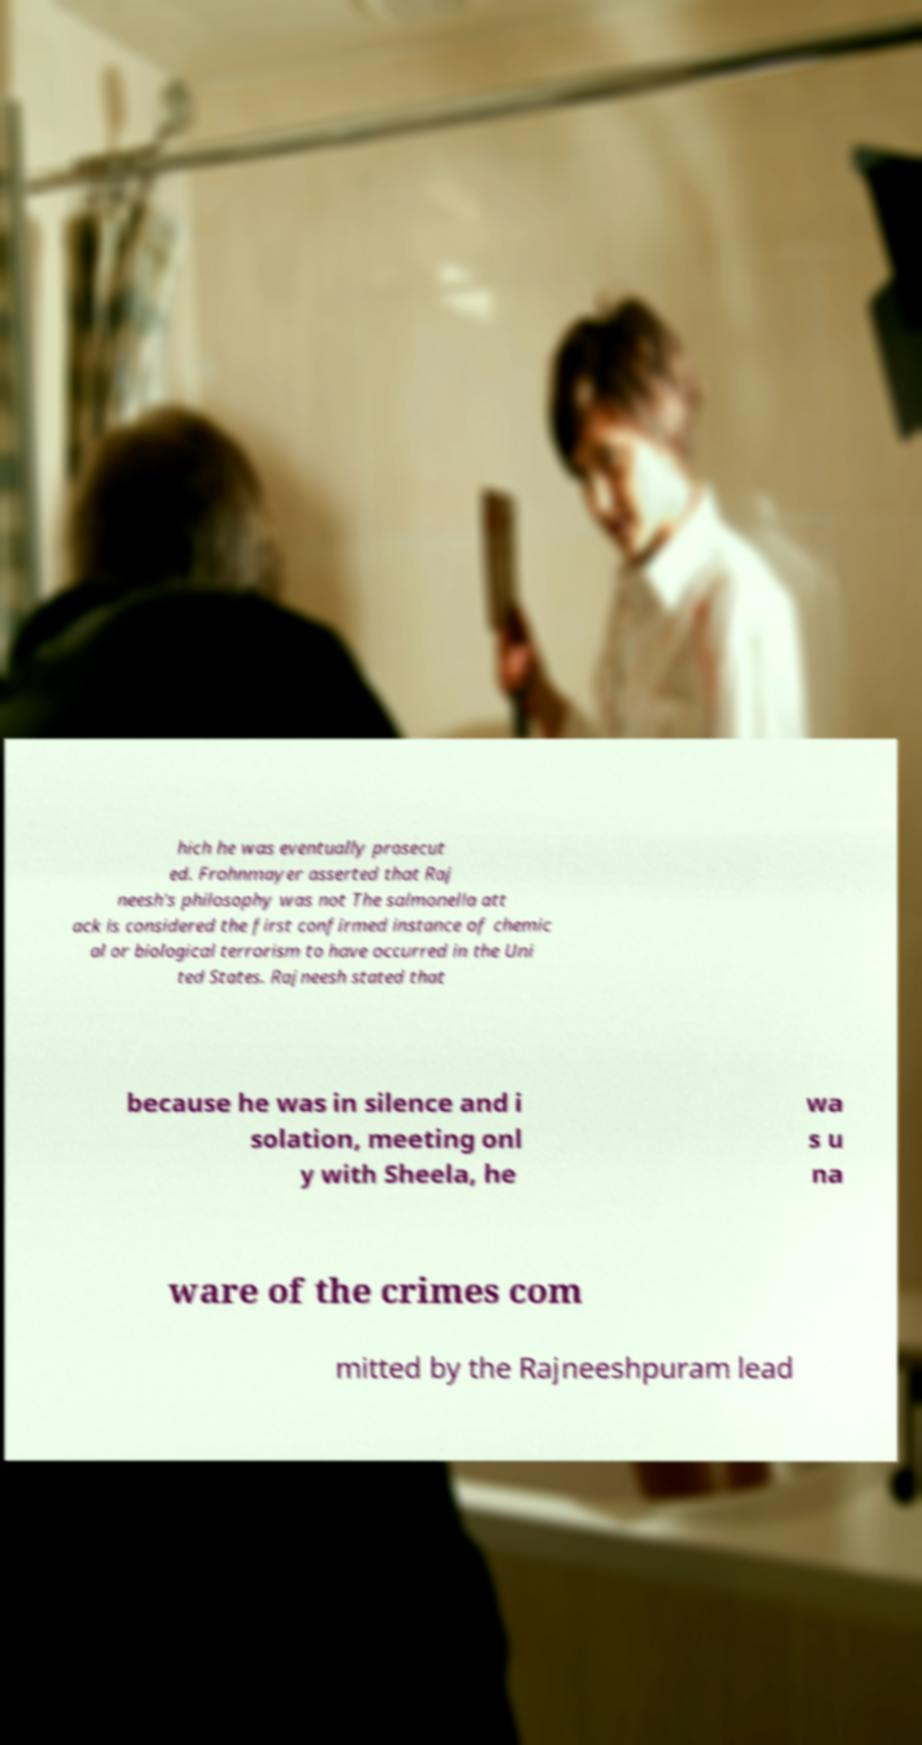Can you accurately transcribe the text from the provided image for me? hich he was eventually prosecut ed. Frohnmayer asserted that Raj neesh's philosophy was not The salmonella att ack is considered the first confirmed instance of chemic al or biological terrorism to have occurred in the Uni ted States. Rajneesh stated that because he was in silence and i solation, meeting onl y with Sheela, he wa s u na ware of the crimes com mitted by the Rajneeshpuram lead 